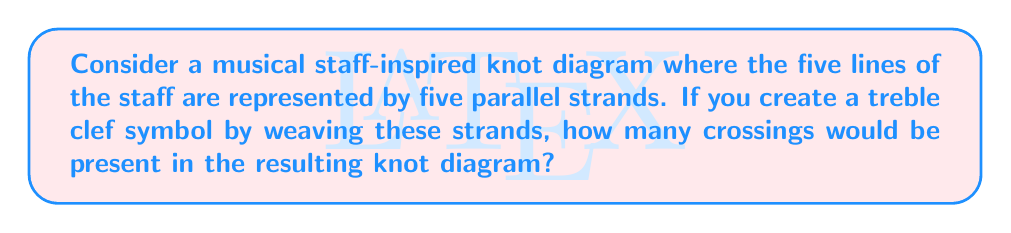Teach me how to tackle this problem. To solve this problem, let's break it down into steps:

1) First, we need to visualize a standard treble clef symbol on a musical staff.

2) Next, we'll count the crossings created by the treble clef symbol:
   - The main loop of the treble clef crosses all five lines once: 5 crossings
   - The top curl crosses the top two lines: 2 crossings
   - The bottom curl crosses the bottom three lines: 3 crossings
   - The central swirl typically crosses four lines twice: 8 crossings

3) Let's sum up all these crossings:
   $$ 5 + 2 + 3 + 8 = 18 $$

4) However, in knot theory, we also need to consider how the strands connect at the ends of the staff. To create a closed loop for each strand, we need to connect the left and right ends. This adds four more crossings (one between each pair of adjacent lines).

5) Therefore, the total number of crossings is:
   $$ 18 + 4 = 22 $$

This approach combines elements of music notation (the treble clef and staff) with knot theory concepts, reflecting the persona of a producer who blends modern and historical musical elements.
Answer: 22 crossings 